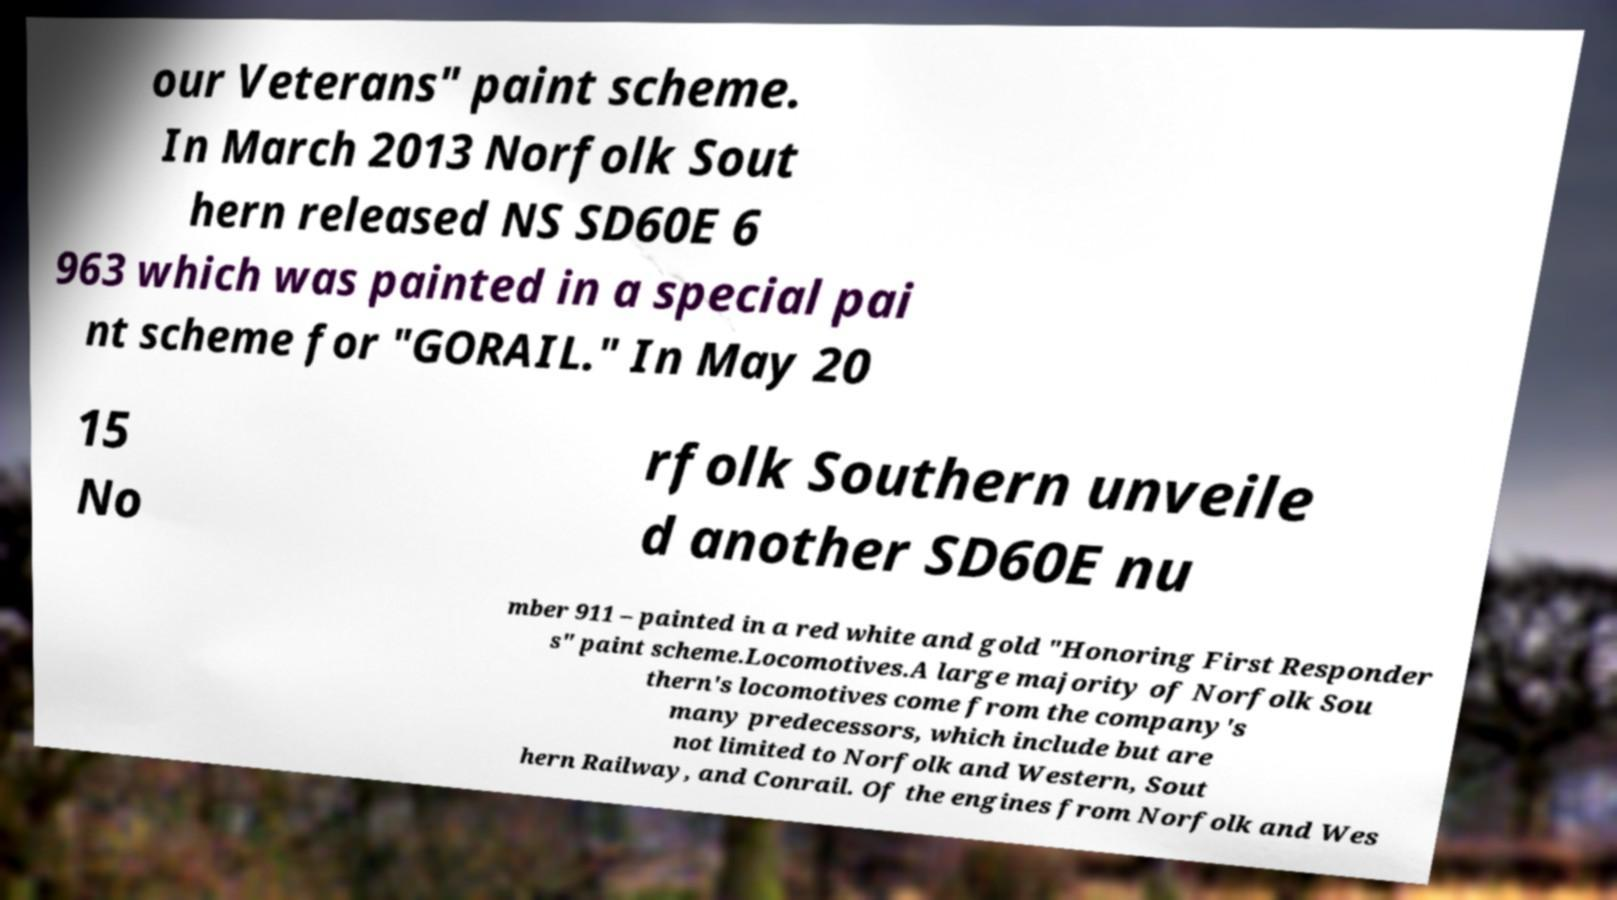Please read and relay the text visible in this image. What does it say? our Veterans" paint scheme. In March 2013 Norfolk Sout hern released NS SD60E 6 963 which was painted in a special pai nt scheme for "GORAIL." In May 20 15 No rfolk Southern unveile d another SD60E nu mber 911 – painted in a red white and gold "Honoring First Responder s" paint scheme.Locomotives.A large majority of Norfolk Sou thern's locomotives come from the company's many predecessors, which include but are not limited to Norfolk and Western, Sout hern Railway, and Conrail. Of the engines from Norfolk and Wes 